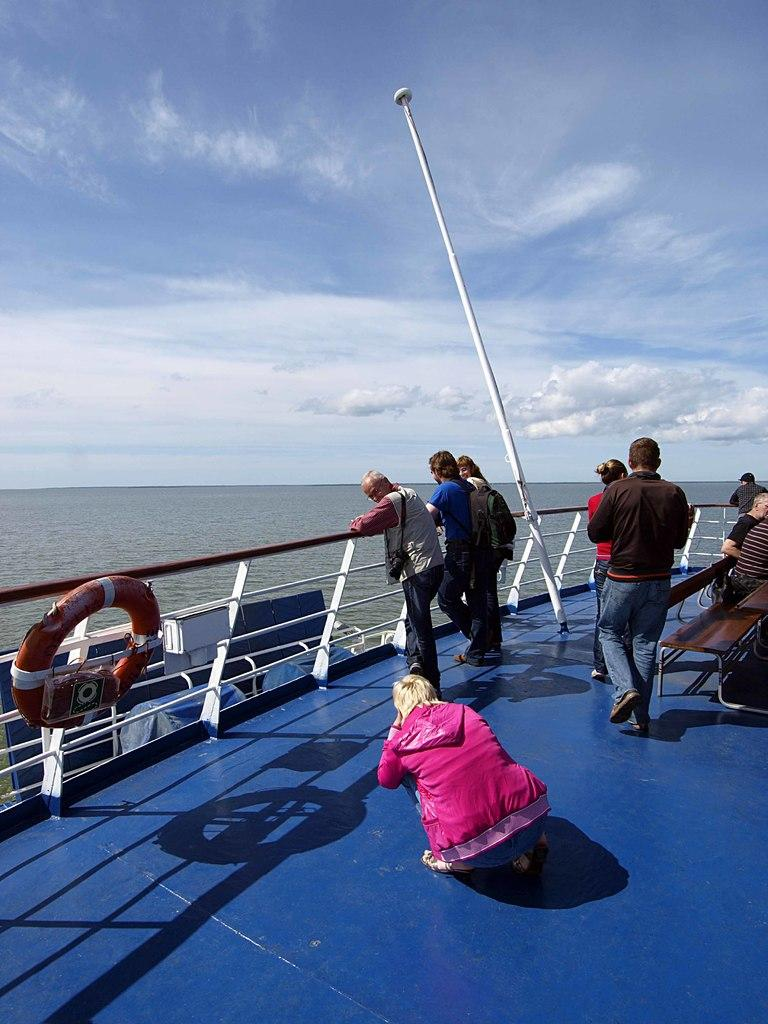What is the main subject of the image? The main subject of the image is a ship. Are there any people on the ship? Yes, there are people on the ship. What can be seen on the ship besides the people? There is a railing with a tube, pole, and benches on the ship. What is visible in the background of the image? Water and sky with clouds are visible in the background of the image. What type of card can be seen being answered by the people on the ship? There is no card or any indication of answering a card present in the image. 